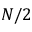Convert formula to latex. <formula><loc_0><loc_0><loc_500><loc_500>N / 2</formula> 